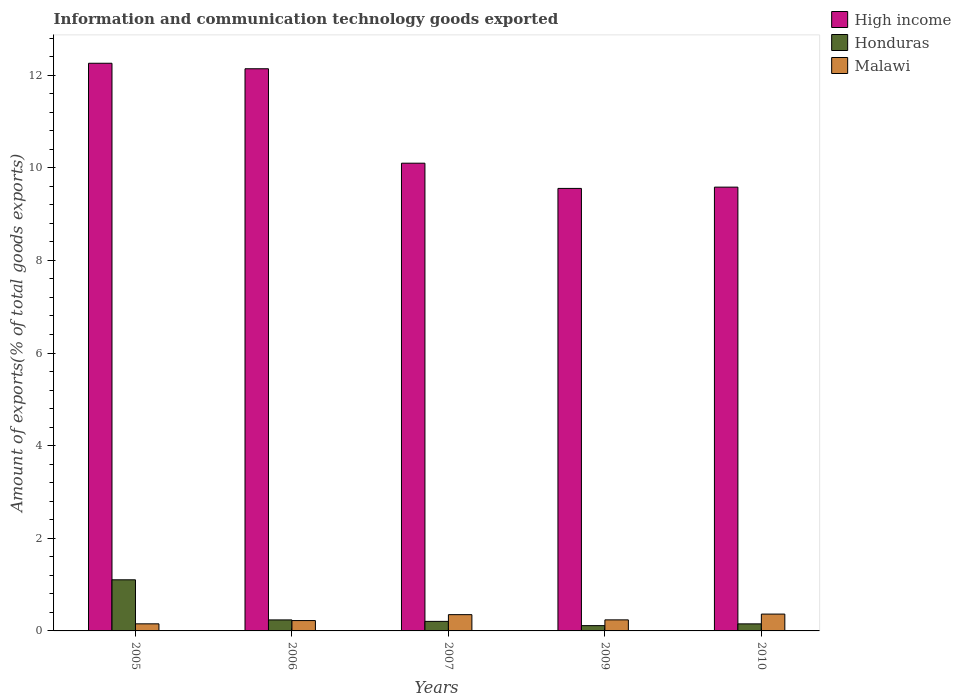How many groups of bars are there?
Give a very brief answer. 5. Are the number of bars per tick equal to the number of legend labels?
Your response must be concise. Yes. In how many cases, is the number of bars for a given year not equal to the number of legend labels?
Your answer should be compact. 0. What is the amount of goods exported in High income in 2006?
Offer a very short reply. 12.14. Across all years, what is the maximum amount of goods exported in Honduras?
Your answer should be very brief. 1.1. Across all years, what is the minimum amount of goods exported in High income?
Your answer should be compact. 9.55. In which year was the amount of goods exported in High income maximum?
Your answer should be compact. 2005. In which year was the amount of goods exported in Honduras minimum?
Provide a short and direct response. 2009. What is the total amount of goods exported in Honduras in the graph?
Provide a succinct answer. 1.81. What is the difference between the amount of goods exported in High income in 2005 and that in 2007?
Provide a short and direct response. 2.16. What is the difference between the amount of goods exported in Honduras in 2005 and the amount of goods exported in High income in 2006?
Offer a terse response. -11.03. What is the average amount of goods exported in Honduras per year?
Your response must be concise. 0.36. In the year 2006, what is the difference between the amount of goods exported in Malawi and amount of goods exported in Honduras?
Your answer should be very brief. -0.01. What is the ratio of the amount of goods exported in Honduras in 2005 to that in 2007?
Your answer should be compact. 5.36. Is the amount of goods exported in Honduras in 2006 less than that in 2007?
Ensure brevity in your answer.  No. Is the difference between the amount of goods exported in Malawi in 2007 and 2010 greater than the difference between the amount of goods exported in Honduras in 2007 and 2010?
Offer a terse response. No. What is the difference between the highest and the second highest amount of goods exported in High income?
Ensure brevity in your answer.  0.12. What is the difference between the highest and the lowest amount of goods exported in Honduras?
Your answer should be compact. 0.99. In how many years, is the amount of goods exported in Malawi greater than the average amount of goods exported in Malawi taken over all years?
Provide a succinct answer. 2. Is the sum of the amount of goods exported in High income in 2006 and 2007 greater than the maximum amount of goods exported in Honduras across all years?
Offer a terse response. Yes. What does the 1st bar from the left in 2009 represents?
Provide a succinct answer. High income. Is it the case that in every year, the sum of the amount of goods exported in Malawi and amount of goods exported in Honduras is greater than the amount of goods exported in High income?
Ensure brevity in your answer.  No. How many bars are there?
Provide a short and direct response. 15. How many years are there in the graph?
Offer a very short reply. 5. What is the difference between two consecutive major ticks on the Y-axis?
Provide a short and direct response. 2. Are the values on the major ticks of Y-axis written in scientific E-notation?
Keep it short and to the point. No. Does the graph contain any zero values?
Make the answer very short. No. Does the graph contain grids?
Provide a short and direct response. No. Where does the legend appear in the graph?
Keep it short and to the point. Top right. How many legend labels are there?
Offer a very short reply. 3. What is the title of the graph?
Give a very brief answer. Information and communication technology goods exported. Does "Luxembourg" appear as one of the legend labels in the graph?
Provide a succinct answer. No. What is the label or title of the Y-axis?
Make the answer very short. Amount of exports(% of total goods exports). What is the Amount of exports(% of total goods exports) in High income in 2005?
Your response must be concise. 12.26. What is the Amount of exports(% of total goods exports) in Honduras in 2005?
Offer a very short reply. 1.1. What is the Amount of exports(% of total goods exports) of Malawi in 2005?
Offer a very short reply. 0.15. What is the Amount of exports(% of total goods exports) of High income in 2006?
Provide a short and direct response. 12.14. What is the Amount of exports(% of total goods exports) in Honduras in 2006?
Keep it short and to the point. 0.24. What is the Amount of exports(% of total goods exports) of Malawi in 2006?
Give a very brief answer. 0.22. What is the Amount of exports(% of total goods exports) of High income in 2007?
Offer a terse response. 10.1. What is the Amount of exports(% of total goods exports) in Honduras in 2007?
Your answer should be compact. 0.21. What is the Amount of exports(% of total goods exports) in Malawi in 2007?
Your answer should be compact. 0.35. What is the Amount of exports(% of total goods exports) of High income in 2009?
Ensure brevity in your answer.  9.55. What is the Amount of exports(% of total goods exports) of Honduras in 2009?
Give a very brief answer. 0.11. What is the Amount of exports(% of total goods exports) of Malawi in 2009?
Ensure brevity in your answer.  0.24. What is the Amount of exports(% of total goods exports) of High income in 2010?
Make the answer very short. 9.58. What is the Amount of exports(% of total goods exports) in Honduras in 2010?
Your answer should be very brief. 0.15. What is the Amount of exports(% of total goods exports) in Malawi in 2010?
Your answer should be very brief. 0.36. Across all years, what is the maximum Amount of exports(% of total goods exports) of High income?
Your answer should be very brief. 12.26. Across all years, what is the maximum Amount of exports(% of total goods exports) of Honduras?
Your answer should be compact. 1.1. Across all years, what is the maximum Amount of exports(% of total goods exports) in Malawi?
Offer a terse response. 0.36. Across all years, what is the minimum Amount of exports(% of total goods exports) of High income?
Make the answer very short. 9.55. Across all years, what is the minimum Amount of exports(% of total goods exports) in Honduras?
Give a very brief answer. 0.11. Across all years, what is the minimum Amount of exports(% of total goods exports) in Malawi?
Offer a terse response. 0.15. What is the total Amount of exports(% of total goods exports) in High income in the graph?
Offer a terse response. 53.63. What is the total Amount of exports(% of total goods exports) in Honduras in the graph?
Your answer should be very brief. 1.81. What is the total Amount of exports(% of total goods exports) in Malawi in the graph?
Your answer should be compact. 1.33. What is the difference between the Amount of exports(% of total goods exports) of High income in 2005 and that in 2006?
Give a very brief answer. 0.12. What is the difference between the Amount of exports(% of total goods exports) in Honduras in 2005 and that in 2006?
Offer a terse response. 0.87. What is the difference between the Amount of exports(% of total goods exports) of Malawi in 2005 and that in 2006?
Your answer should be very brief. -0.07. What is the difference between the Amount of exports(% of total goods exports) of High income in 2005 and that in 2007?
Provide a succinct answer. 2.16. What is the difference between the Amount of exports(% of total goods exports) of Honduras in 2005 and that in 2007?
Keep it short and to the point. 0.9. What is the difference between the Amount of exports(% of total goods exports) of Malawi in 2005 and that in 2007?
Give a very brief answer. -0.2. What is the difference between the Amount of exports(% of total goods exports) in High income in 2005 and that in 2009?
Your response must be concise. 2.7. What is the difference between the Amount of exports(% of total goods exports) of Honduras in 2005 and that in 2009?
Offer a very short reply. 0.99. What is the difference between the Amount of exports(% of total goods exports) of Malawi in 2005 and that in 2009?
Your answer should be very brief. -0.09. What is the difference between the Amount of exports(% of total goods exports) in High income in 2005 and that in 2010?
Keep it short and to the point. 2.67. What is the difference between the Amount of exports(% of total goods exports) in Honduras in 2005 and that in 2010?
Give a very brief answer. 0.95. What is the difference between the Amount of exports(% of total goods exports) in Malawi in 2005 and that in 2010?
Your answer should be compact. -0.21. What is the difference between the Amount of exports(% of total goods exports) of High income in 2006 and that in 2007?
Ensure brevity in your answer.  2.04. What is the difference between the Amount of exports(% of total goods exports) in Honduras in 2006 and that in 2007?
Offer a terse response. 0.03. What is the difference between the Amount of exports(% of total goods exports) of Malawi in 2006 and that in 2007?
Give a very brief answer. -0.13. What is the difference between the Amount of exports(% of total goods exports) of High income in 2006 and that in 2009?
Offer a terse response. 2.58. What is the difference between the Amount of exports(% of total goods exports) in Honduras in 2006 and that in 2009?
Provide a short and direct response. 0.12. What is the difference between the Amount of exports(% of total goods exports) of Malawi in 2006 and that in 2009?
Keep it short and to the point. -0.02. What is the difference between the Amount of exports(% of total goods exports) in High income in 2006 and that in 2010?
Provide a short and direct response. 2.56. What is the difference between the Amount of exports(% of total goods exports) in Honduras in 2006 and that in 2010?
Make the answer very short. 0.09. What is the difference between the Amount of exports(% of total goods exports) in Malawi in 2006 and that in 2010?
Your response must be concise. -0.14. What is the difference between the Amount of exports(% of total goods exports) of High income in 2007 and that in 2009?
Make the answer very short. 0.54. What is the difference between the Amount of exports(% of total goods exports) of Honduras in 2007 and that in 2009?
Your answer should be very brief. 0.09. What is the difference between the Amount of exports(% of total goods exports) of Malawi in 2007 and that in 2009?
Your response must be concise. 0.11. What is the difference between the Amount of exports(% of total goods exports) in High income in 2007 and that in 2010?
Keep it short and to the point. 0.52. What is the difference between the Amount of exports(% of total goods exports) in Honduras in 2007 and that in 2010?
Provide a short and direct response. 0.05. What is the difference between the Amount of exports(% of total goods exports) in Malawi in 2007 and that in 2010?
Provide a short and direct response. -0.01. What is the difference between the Amount of exports(% of total goods exports) of High income in 2009 and that in 2010?
Offer a terse response. -0.03. What is the difference between the Amount of exports(% of total goods exports) in Honduras in 2009 and that in 2010?
Provide a succinct answer. -0.04. What is the difference between the Amount of exports(% of total goods exports) in Malawi in 2009 and that in 2010?
Make the answer very short. -0.12. What is the difference between the Amount of exports(% of total goods exports) of High income in 2005 and the Amount of exports(% of total goods exports) of Honduras in 2006?
Ensure brevity in your answer.  12.02. What is the difference between the Amount of exports(% of total goods exports) in High income in 2005 and the Amount of exports(% of total goods exports) in Malawi in 2006?
Keep it short and to the point. 12.03. What is the difference between the Amount of exports(% of total goods exports) of Honduras in 2005 and the Amount of exports(% of total goods exports) of Malawi in 2006?
Your answer should be very brief. 0.88. What is the difference between the Amount of exports(% of total goods exports) in High income in 2005 and the Amount of exports(% of total goods exports) in Honduras in 2007?
Your answer should be very brief. 12.05. What is the difference between the Amount of exports(% of total goods exports) in High income in 2005 and the Amount of exports(% of total goods exports) in Malawi in 2007?
Keep it short and to the point. 11.91. What is the difference between the Amount of exports(% of total goods exports) of Honduras in 2005 and the Amount of exports(% of total goods exports) of Malawi in 2007?
Ensure brevity in your answer.  0.75. What is the difference between the Amount of exports(% of total goods exports) of High income in 2005 and the Amount of exports(% of total goods exports) of Honduras in 2009?
Offer a very short reply. 12.14. What is the difference between the Amount of exports(% of total goods exports) of High income in 2005 and the Amount of exports(% of total goods exports) of Malawi in 2009?
Offer a very short reply. 12.02. What is the difference between the Amount of exports(% of total goods exports) in Honduras in 2005 and the Amount of exports(% of total goods exports) in Malawi in 2009?
Make the answer very short. 0.86. What is the difference between the Amount of exports(% of total goods exports) in High income in 2005 and the Amount of exports(% of total goods exports) in Honduras in 2010?
Your response must be concise. 12.1. What is the difference between the Amount of exports(% of total goods exports) in High income in 2005 and the Amount of exports(% of total goods exports) in Malawi in 2010?
Your answer should be compact. 11.89. What is the difference between the Amount of exports(% of total goods exports) of Honduras in 2005 and the Amount of exports(% of total goods exports) of Malawi in 2010?
Your response must be concise. 0.74. What is the difference between the Amount of exports(% of total goods exports) of High income in 2006 and the Amount of exports(% of total goods exports) of Honduras in 2007?
Your response must be concise. 11.93. What is the difference between the Amount of exports(% of total goods exports) of High income in 2006 and the Amount of exports(% of total goods exports) of Malawi in 2007?
Offer a very short reply. 11.79. What is the difference between the Amount of exports(% of total goods exports) in Honduras in 2006 and the Amount of exports(% of total goods exports) in Malawi in 2007?
Make the answer very short. -0.11. What is the difference between the Amount of exports(% of total goods exports) of High income in 2006 and the Amount of exports(% of total goods exports) of Honduras in 2009?
Keep it short and to the point. 12.02. What is the difference between the Amount of exports(% of total goods exports) of High income in 2006 and the Amount of exports(% of total goods exports) of Malawi in 2009?
Give a very brief answer. 11.9. What is the difference between the Amount of exports(% of total goods exports) in Honduras in 2006 and the Amount of exports(% of total goods exports) in Malawi in 2009?
Make the answer very short. -0. What is the difference between the Amount of exports(% of total goods exports) in High income in 2006 and the Amount of exports(% of total goods exports) in Honduras in 2010?
Provide a succinct answer. 11.99. What is the difference between the Amount of exports(% of total goods exports) in High income in 2006 and the Amount of exports(% of total goods exports) in Malawi in 2010?
Offer a very short reply. 11.77. What is the difference between the Amount of exports(% of total goods exports) of Honduras in 2006 and the Amount of exports(% of total goods exports) of Malawi in 2010?
Give a very brief answer. -0.13. What is the difference between the Amount of exports(% of total goods exports) of High income in 2007 and the Amount of exports(% of total goods exports) of Honduras in 2009?
Keep it short and to the point. 9.99. What is the difference between the Amount of exports(% of total goods exports) of High income in 2007 and the Amount of exports(% of total goods exports) of Malawi in 2009?
Your response must be concise. 9.86. What is the difference between the Amount of exports(% of total goods exports) of Honduras in 2007 and the Amount of exports(% of total goods exports) of Malawi in 2009?
Offer a very short reply. -0.03. What is the difference between the Amount of exports(% of total goods exports) of High income in 2007 and the Amount of exports(% of total goods exports) of Honduras in 2010?
Offer a terse response. 9.95. What is the difference between the Amount of exports(% of total goods exports) in High income in 2007 and the Amount of exports(% of total goods exports) in Malawi in 2010?
Provide a short and direct response. 9.74. What is the difference between the Amount of exports(% of total goods exports) of Honduras in 2007 and the Amount of exports(% of total goods exports) of Malawi in 2010?
Give a very brief answer. -0.16. What is the difference between the Amount of exports(% of total goods exports) in High income in 2009 and the Amount of exports(% of total goods exports) in Honduras in 2010?
Offer a terse response. 9.4. What is the difference between the Amount of exports(% of total goods exports) in High income in 2009 and the Amount of exports(% of total goods exports) in Malawi in 2010?
Ensure brevity in your answer.  9.19. What is the difference between the Amount of exports(% of total goods exports) in Honduras in 2009 and the Amount of exports(% of total goods exports) in Malawi in 2010?
Your response must be concise. -0.25. What is the average Amount of exports(% of total goods exports) in High income per year?
Your answer should be compact. 10.73. What is the average Amount of exports(% of total goods exports) in Honduras per year?
Offer a terse response. 0.36. What is the average Amount of exports(% of total goods exports) of Malawi per year?
Keep it short and to the point. 0.27. In the year 2005, what is the difference between the Amount of exports(% of total goods exports) in High income and Amount of exports(% of total goods exports) in Honduras?
Your answer should be very brief. 11.15. In the year 2005, what is the difference between the Amount of exports(% of total goods exports) of High income and Amount of exports(% of total goods exports) of Malawi?
Ensure brevity in your answer.  12.1. In the year 2005, what is the difference between the Amount of exports(% of total goods exports) of Honduras and Amount of exports(% of total goods exports) of Malawi?
Provide a succinct answer. 0.95. In the year 2006, what is the difference between the Amount of exports(% of total goods exports) of High income and Amount of exports(% of total goods exports) of Honduras?
Make the answer very short. 11.9. In the year 2006, what is the difference between the Amount of exports(% of total goods exports) of High income and Amount of exports(% of total goods exports) of Malawi?
Give a very brief answer. 11.91. In the year 2006, what is the difference between the Amount of exports(% of total goods exports) of Honduras and Amount of exports(% of total goods exports) of Malawi?
Offer a terse response. 0.01. In the year 2007, what is the difference between the Amount of exports(% of total goods exports) in High income and Amount of exports(% of total goods exports) in Honduras?
Offer a terse response. 9.89. In the year 2007, what is the difference between the Amount of exports(% of total goods exports) in High income and Amount of exports(% of total goods exports) in Malawi?
Provide a short and direct response. 9.75. In the year 2007, what is the difference between the Amount of exports(% of total goods exports) of Honduras and Amount of exports(% of total goods exports) of Malawi?
Make the answer very short. -0.15. In the year 2009, what is the difference between the Amount of exports(% of total goods exports) in High income and Amount of exports(% of total goods exports) in Honduras?
Keep it short and to the point. 9.44. In the year 2009, what is the difference between the Amount of exports(% of total goods exports) of High income and Amount of exports(% of total goods exports) of Malawi?
Your answer should be compact. 9.32. In the year 2009, what is the difference between the Amount of exports(% of total goods exports) in Honduras and Amount of exports(% of total goods exports) in Malawi?
Make the answer very short. -0.12. In the year 2010, what is the difference between the Amount of exports(% of total goods exports) of High income and Amount of exports(% of total goods exports) of Honduras?
Provide a short and direct response. 9.43. In the year 2010, what is the difference between the Amount of exports(% of total goods exports) of High income and Amount of exports(% of total goods exports) of Malawi?
Provide a succinct answer. 9.22. In the year 2010, what is the difference between the Amount of exports(% of total goods exports) in Honduras and Amount of exports(% of total goods exports) in Malawi?
Provide a short and direct response. -0.21. What is the ratio of the Amount of exports(% of total goods exports) in High income in 2005 to that in 2006?
Your answer should be very brief. 1.01. What is the ratio of the Amount of exports(% of total goods exports) of Honduras in 2005 to that in 2006?
Ensure brevity in your answer.  4.64. What is the ratio of the Amount of exports(% of total goods exports) of Malawi in 2005 to that in 2006?
Provide a short and direct response. 0.69. What is the ratio of the Amount of exports(% of total goods exports) in High income in 2005 to that in 2007?
Your answer should be very brief. 1.21. What is the ratio of the Amount of exports(% of total goods exports) of Honduras in 2005 to that in 2007?
Your answer should be very brief. 5.36. What is the ratio of the Amount of exports(% of total goods exports) in Malawi in 2005 to that in 2007?
Offer a very short reply. 0.44. What is the ratio of the Amount of exports(% of total goods exports) in High income in 2005 to that in 2009?
Provide a succinct answer. 1.28. What is the ratio of the Amount of exports(% of total goods exports) of Honduras in 2005 to that in 2009?
Your response must be concise. 9.67. What is the ratio of the Amount of exports(% of total goods exports) of Malawi in 2005 to that in 2009?
Your answer should be compact. 0.64. What is the ratio of the Amount of exports(% of total goods exports) in High income in 2005 to that in 2010?
Your answer should be compact. 1.28. What is the ratio of the Amount of exports(% of total goods exports) in Honduras in 2005 to that in 2010?
Your answer should be very brief. 7.25. What is the ratio of the Amount of exports(% of total goods exports) of Malawi in 2005 to that in 2010?
Provide a short and direct response. 0.42. What is the ratio of the Amount of exports(% of total goods exports) of High income in 2006 to that in 2007?
Offer a very short reply. 1.2. What is the ratio of the Amount of exports(% of total goods exports) in Honduras in 2006 to that in 2007?
Provide a short and direct response. 1.15. What is the ratio of the Amount of exports(% of total goods exports) of Malawi in 2006 to that in 2007?
Your answer should be compact. 0.64. What is the ratio of the Amount of exports(% of total goods exports) in High income in 2006 to that in 2009?
Your answer should be very brief. 1.27. What is the ratio of the Amount of exports(% of total goods exports) of Honduras in 2006 to that in 2009?
Offer a very short reply. 2.08. What is the ratio of the Amount of exports(% of total goods exports) in Malawi in 2006 to that in 2009?
Your response must be concise. 0.94. What is the ratio of the Amount of exports(% of total goods exports) of High income in 2006 to that in 2010?
Provide a short and direct response. 1.27. What is the ratio of the Amount of exports(% of total goods exports) in Honduras in 2006 to that in 2010?
Your answer should be compact. 1.56. What is the ratio of the Amount of exports(% of total goods exports) in Malawi in 2006 to that in 2010?
Give a very brief answer. 0.61. What is the ratio of the Amount of exports(% of total goods exports) in High income in 2007 to that in 2009?
Give a very brief answer. 1.06. What is the ratio of the Amount of exports(% of total goods exports) in Honduras in 2007 to that in 2009?
Your answer should be compact. 1.81. What is the ratio of the Amount of exports(% of total goods exports) in Malawi in 2007 to that in 2009?
Offer a terse response. 1.47. What is the ratio of the Amount of exports(% of total goods exports) of High income in 2007 to that in 2010?
Your answer should be compact. 1.05. What is the ratio of the Amount of exports(% of total goods exports) in Honduras in 2007 to that in 2010?
Offer a very short reply. 1.35. What is the ratio of the Amount of exports(% of total goods exports) in Malawi in 2007 to that in 2010?
Give a very brief answer. 0.97. What is the ratio of the Amount of exports(% of total goods exports) of Honduras in 2009 to that in 2010?
Give a very brief answer. 0.75. What is the ratio of the Amount of exports(% of total goods exports) of Malawi in 2009 to that in 2010?
Provide a short and direct response. 0.66. What is the difference between the highest and the second highest Amount of exports(% of total goods exports) of High income?
Offer a terse response. 0.12. What is the difference between the highest and the second highest Amount of exports(% of total goods exports) in Honduras?
Your answer should be very brief. 0.87. What is the difference between the highest and the second highest Amount of exports(% of total goods exports) of Malawi?
Give a very brief answer. 0.01. What is the difference between the highest and the lowest Amount of exports(% of total goods exports) in High income?
Offer a very short reply. 2.7. What is the difference between the highest and the lowest Amount of exports(% of total goods exports) in Malawi?
Ensure brevity in your answer.  0.21. 